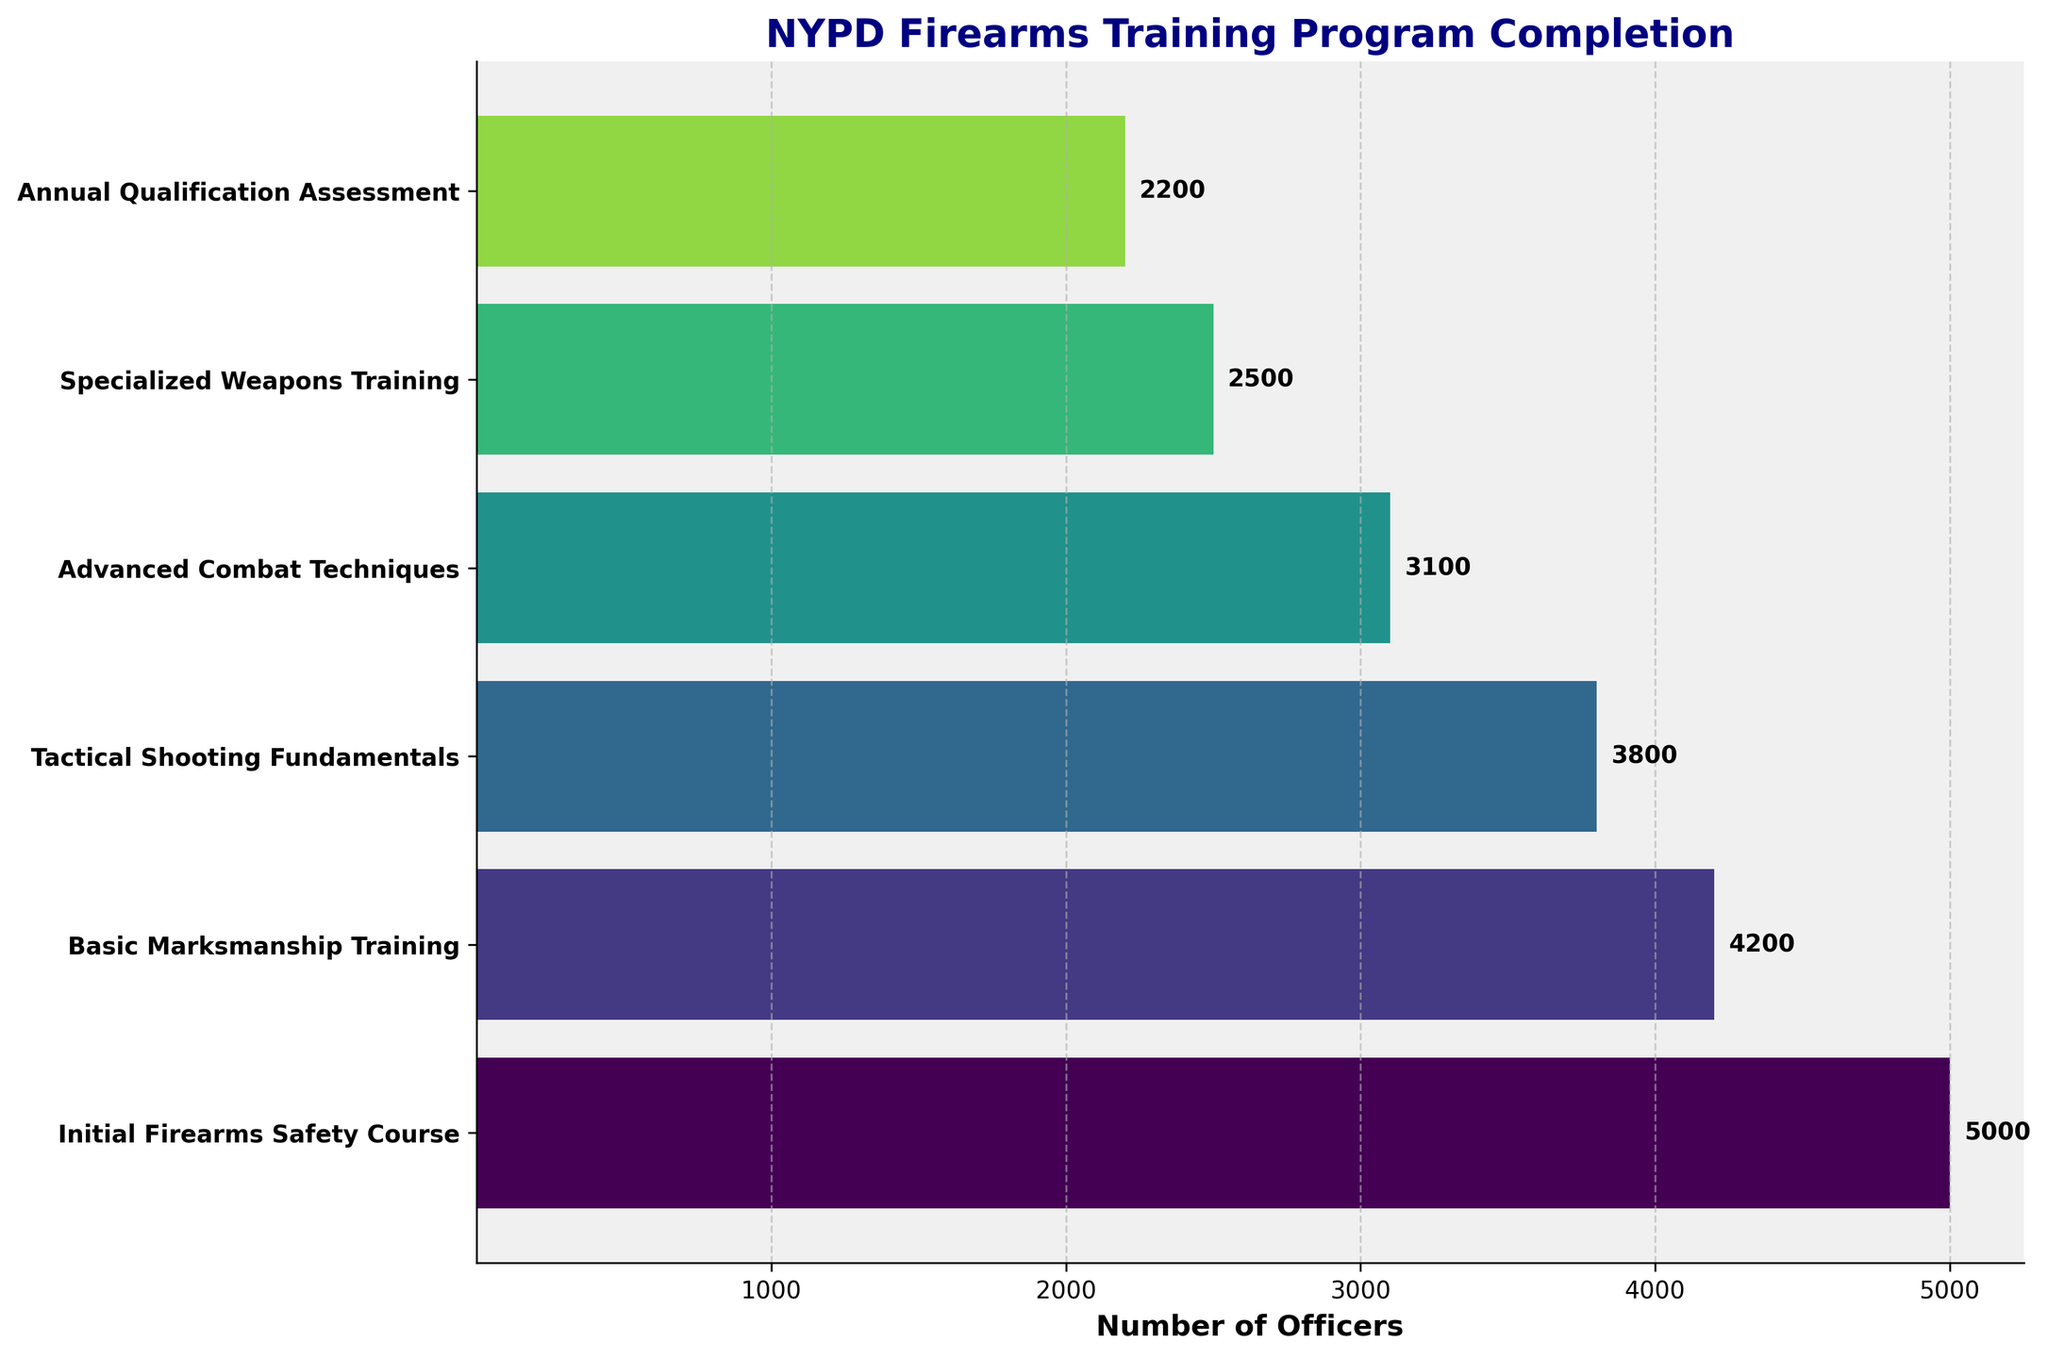What is the title of the chart? The title is displayed at the top of the chart and it reads "NYPD Firearms Training Program Completion".
Answer: NYPD Firearms Training Program Completion How many stages are shown in the training program? The number of stages can be determined by counting the number of labels on the y-axis or the horizontal bars.
Answer: 6 Which stage has the highest number of officers completed? Looking at the length of the horizontal bars, the first stage "Initial Firearms Safety Course" has the longest bar, indicating the most officers completed.
Answer: Initial Firearms Safety Course How many officers completed the Tactical Shooting Fundamentals stage? Read off the value label at the end of the bar corresponding to the "Tactical Shooting Fundamentals" stage.
Answer: 3800 What is the difference in the number of completions between the Initial Firearms Safety Course and the Annual Qualification Assessment? Subtract the number of completions for the Annual Qualification Assessment from those of the Initial Firearms Safety Course. 5000 - 2200 = 2800
Answer: 2800 Which stage witnessed the highest drop in completion numbers compared to the previous stage? Compare the differences between successive stages' completion numbers and identify the largest drop. The biggest drop is between "Tactical Shooting Fundamentals" (3800) to "Advanced Combat Techniques" (3100), a difference of 700 officers.
Answer: Tactical Shooting Fundamentals to Advanced Combat Techniques Are there more officers who completed the Advanced Combat Techniques stage than the Basic Marksmanship Training stage? Compare the number of completions between "Advanced Combat Techniques" (3100) and "Basic Marksmanship Training" (4200). 3100 is less than 4200.
Answer: No What percentage of officers completed the Specialized Weapons Training stage out of those who completed the Initial Firearms Safety Course? Divide the number of officers completing "Specialized Weapons Training" (2500) by those completing the "Initial Firearms Safety Course" (5000), then multiply by 100 to convert to percentage. (2500 / 5000) * 100 = 50%
Answer: 50% What is the average number of officers who completed each stage? Sum up the number of completions for all stages and divide by the number of stages. (5000 + 4200 + 3800 + 3100 + 2500 + 2200) / 6 ≈ 3467
Answer: 3467 How does the number of completions in the Annual Qualification Assessment compare to the Advanced Combat Techniques stage? Determine the relationship by comparing the numbers: 2200 officers (Annual Qualification Assessment) versus 3100 officers (Advanced Combat Techniques). 2200 is less than 3100.
Answer: Less 